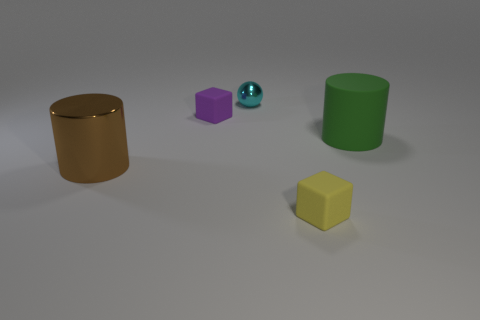Do the cyan object that is right of the brown cylinder and the tiny matte object that is behind the tiny yellow rubber block have the same shape?
Ensure brevity in your answer.  No. What number of cubes are either matte objects or yellow objects?
Your answer should be compact. 2. Are there fewer brown cylinders behind the large green matte thing than cyan metallic things?
Provide a short and direct response. Yes. What number of other things are the same material as the large brown thing?
Offer a very short reply. 1. Is the yellow rubber block the same size as the purple rubber block?
Your answer should be very brief. Yes. What number of objects are blocks that are behind the big shiny cylinder or large green rubber cylinders?
Your answer should be compact. 2. What is the cylinder that is on the right side of the object that is left of the tiny purple thing made of?
Keep it short and to the point. Rubber. Is there a tiny purple matte thing of the same shape as the tiny yellow thing?
Provide a short and direct response. Yes. There is a yellow block; is its size the same as the cube that is behind the yellow object?
Offer a terse response. Yes. What number of things are matte objects in front of the purple thing or objects that are on the right side of the purple matte cube?
Your answer should be compact. 3. 